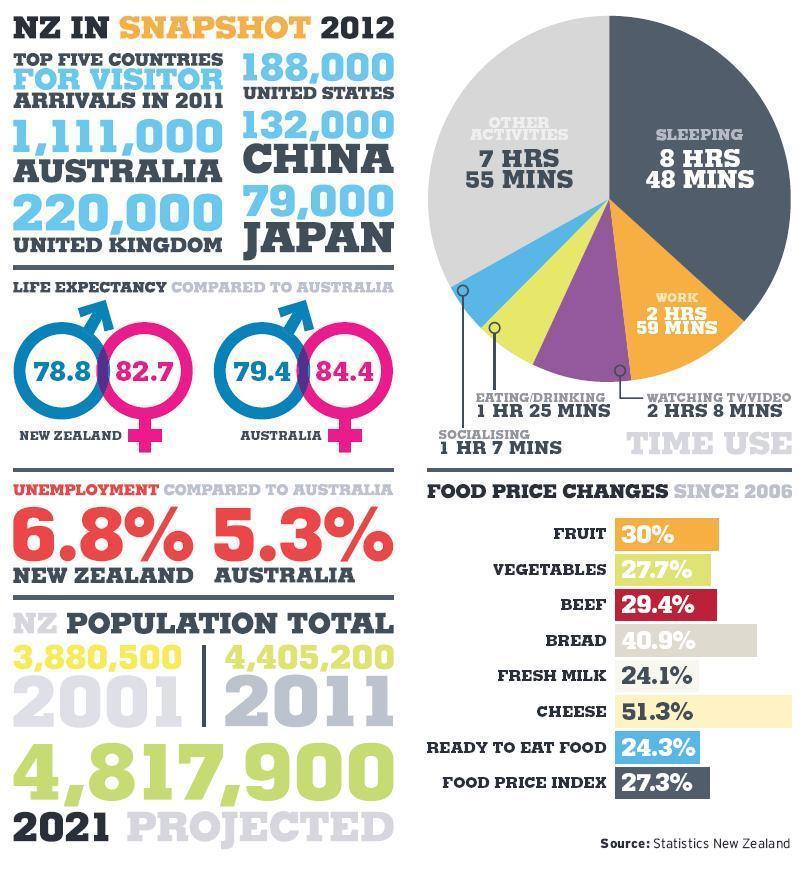What is the food price change of beef and bread, taken together?
Answer the question with a short phrase. 70.3% What is the life expectancy of females in New Zealand? 82.7 What is the life expectancy of males in Australia? 79.4 What is the life expectancy of females in Australia? 84.4 What is the food price change of fruit and vegetables, taken together? 57.7% What is the food price change of fresh milk and cheese, taken together? 75.4% What is the difference between the unemployment rate of New Zealand and Australia? 1.5% Which activity has the highest share-other activities, sleeping? sleeping What is the food price change of ready to eat food and food price index, taken together? 51.6% 